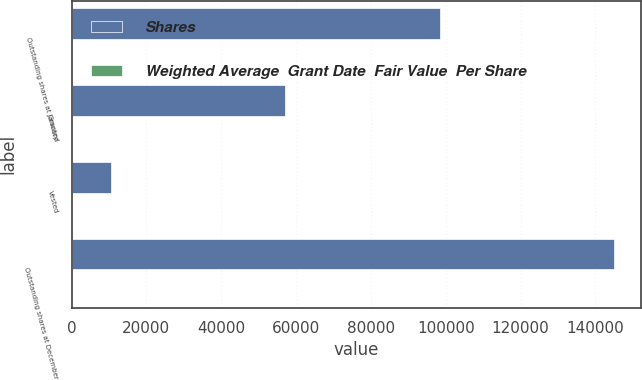Convert chart. <chart><loc_0><loc_0><loc_500><loc_500><stacked_bar_chart><ecel><fcel>Outstanding shares at January<fcel>Granted<fcel>Vested<fcel>Outstanding shares at December<nl><fcel>Shares<fcel>98334<fcel>57100<fcel>10416<fcel>145018<nl><fcel>Weighted Average  Grant Date  Fair Value  Per Share<fcel>73.42<fcel>69.57<fcel>68.73<fcel>72.03<nl></chart> 